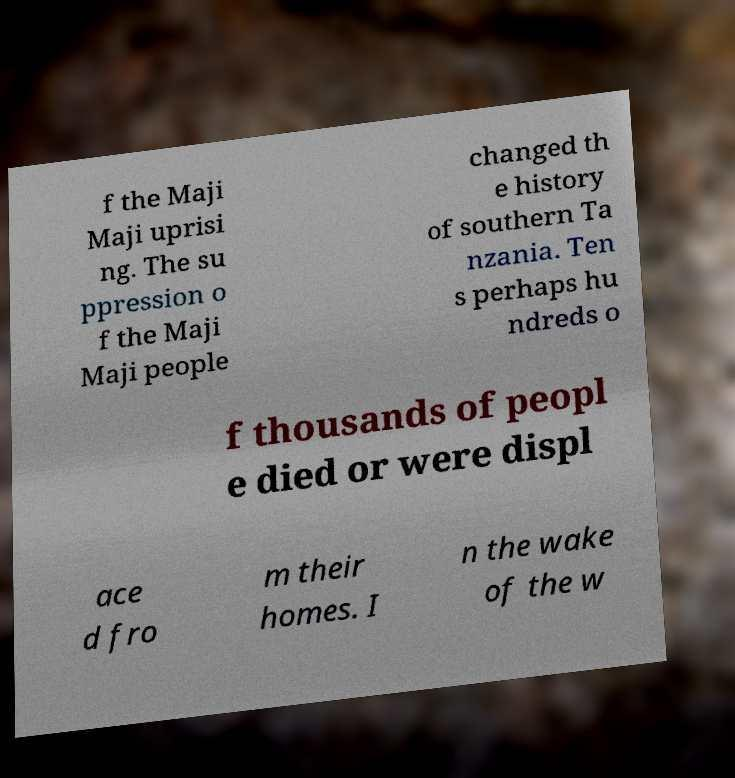Could you extract and type out the text from this image? f the Maji Maji uprisi ng. The su ppression o f the Maji Maji people changed th e history of southern Ta nzania. Ten s perhaps hu ndreds o f thousands of peopl e died or were displ ace d fro m their homes. I n the wake of the w 